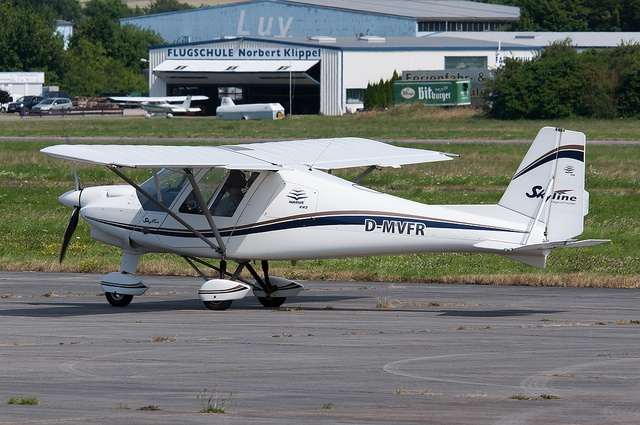Describe the objects in this image and their specific colors. I can see airplane in darkgreen, lightgray, gray, black, and darkgray tones, people in darkgreen, black, and gray tones, airplane in darkgreen, gray, darkgray, lightgray, and black tones, car in darkgreen, darkgray, gray, black, and navy tones, and car in darkgreen, black, navy, gray, and blue tones in this image. 